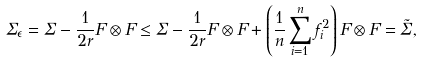Convert formula to latex. <formula><loc_0><loc_0><loc_500><loc_500>\Sigma _ { \epsilon } = \Sigma - \frac { 1 } { 2 r } F \otimes F \leq \Sigma - \frac { 1 } { 2 r } F \otimes F + \left ( \frac { 1 } { n } \sum _ { i = 1 } ^ { n } f _ { i } ^ { 2 } \right ) F \otimes F = \tilde { \Sigma } ,</formula> 